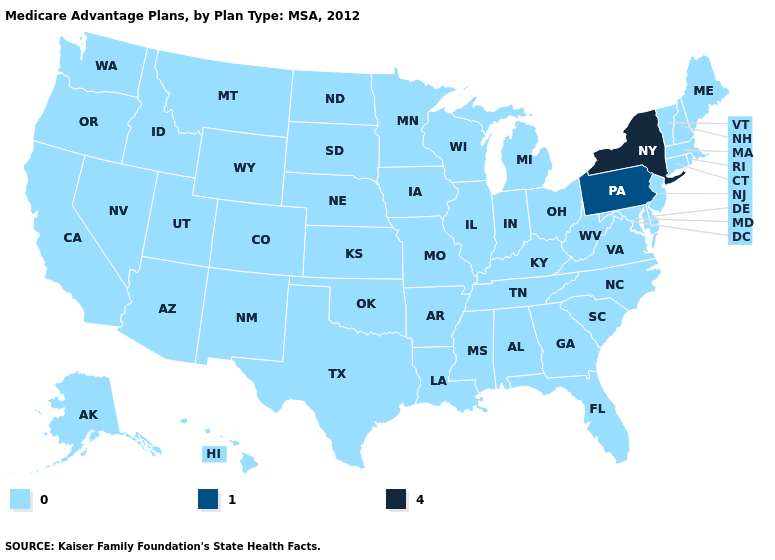Name the states that have a value in the range 4?
Concise answer only. New York. How many symbols are there in the legend?
Keep it brief. 3. Name the states that have a value in the range 0?
Short answer required. Alaska, Alabama, Arkansas, Arizona, California, Colorado, Connecticut, Delaware, Florida, Georgia, Hawaii, Iowa, Idaho, Illinois, Indiana, Kansas, Kentucky, Louisiana, Massachusetts, Maryland, Maine, Michigan, Minnesota, Missouri, Mississippi, Montana, North Carolina, North Dakota, Nebraska, New Hampshire, New Jersey, New Mexico, Nevada, Ohio, Oklahoma, Oregon, Rhode Island, South Carolina, South Dakota, Tennessee, Texas, Utah, Virginia, Vermont, Washington, Wisconsin, West Virginia, Wyoming. Among the states that border Ohio , which have the highest value?
Concise answer only. Pennsylvania. Name the states that have a value in the range 0?
Quick response, please. Alaska, Alabama, Arkansas, Arizona, California, Colorado, Connecticut, Delaware, Florida, Georgia, Hawaii, Iowa, Idaho, Illinois, Indiana, Kansas, Kentucky, Louisiana, Massachusetts, Maryland, Maine, Michigan, Minnesota, Missouri, Mississippi, Montana, North Carolina, North Dakota, Nebraska, New Hampshire, New Jersey, New Mexico, Nevada, Ohio, Oklahoma, Oregon, Rhode Island, South Carolina, South Dakota, Tennessee, Texas, Utah, Virginia, Vermont, Washington, Wisconsin, West Virginia, Wyoming. What is the value of Ohio?
Quick response, please. 0. Does Delaware have the lowest value in the USA?
Write a very short answer. Yes. Name the states that have a value in the range 4?
Be succinct. New York. Which states have the lowest value in the USA?
Write a very short answer. Alaska, Alabama, Arkansas, Arizona, California, Colorado, Connecticut, Delaware, Florida, Georgia, Hawaii, Iowa, Idaho, Illinois, Indiana, Kansas, Kentucky, Louisiana, Massachusetts, Maryland, Maine, Michigan, Minnesota, Missouri, Mississippi, Montana, North Carolina, North Dakota, Nebraska, New Hampshire, New Jersey, New Mexico, Nevada, Ohio, Oklahoma, Oregon, Rhode Island, South Carolina, South Dakota, Tennessee, Texas, Utah, Virginia, Vermont, Washington, Wisconsin, West Virginia, Wyoming. What is the lowest value in the USA?
Give a very brief answer. 0. Among the states that border Alabama , which have the highest value?
Give a very brief answer. Florida, Georgia, Mississippi, Tennessee. What is the value of Washington?
Quick response, please. 0. What is the value of Massachusetts?
Short answer required. 0. 